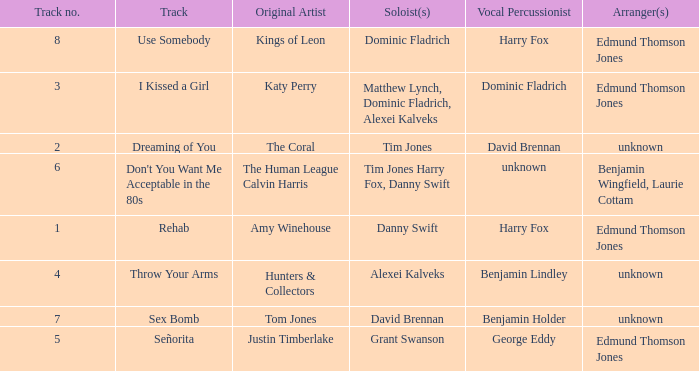Who is the vocal percussionist for Sex Bomb? Benjamin Holder. 